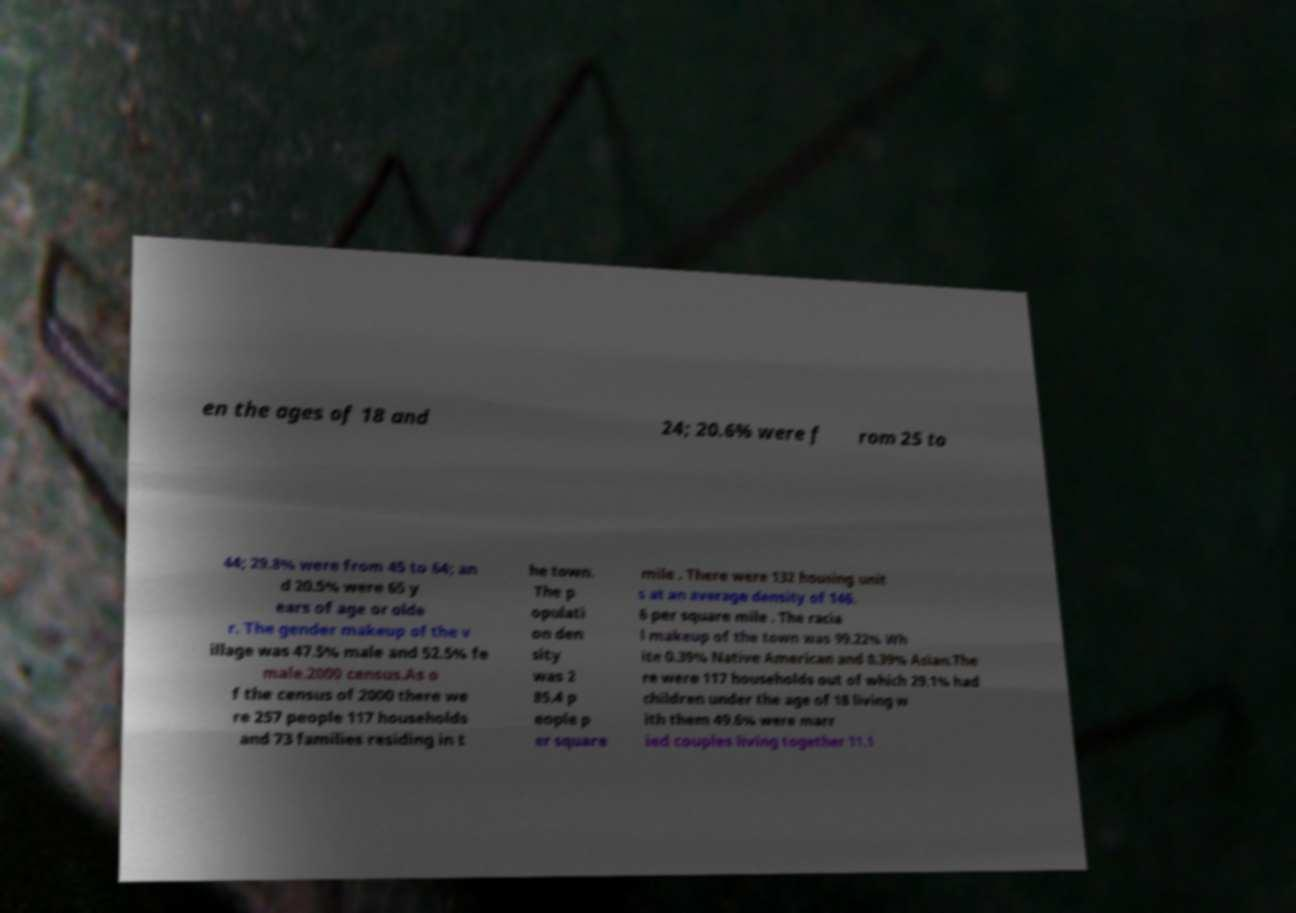There's text embedded in this image that I need extracted. Can you transcribe it verbatim? en the ages of 18 and 24; 20.6% were f rom 25 to 44; 29.8% were from 45 to 64; an d 20.5% were 65 y ears of age or olde r. The gender makeup of the v illage was 47.5% male and 52.5% fe male.2000 census.As o f the census of 2000 there we re 257 people 117 households and 73 families residing in t he town. The p opulati on den sity was 2 85.4 p eople p er square mile . There were 132 housing unit s at an average density of 146. 6 per square mile . The racia l makeup of the town was 99.22% Wh ite 0.39% Native American and 0.39% Asian.The re were 117 households out of which 29.1% had children under the age of 18 living w ith them 49.6% were marr ied couples living together 11.1 